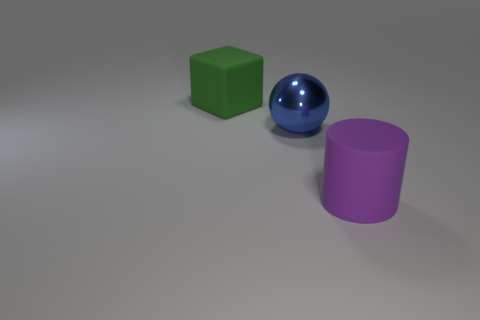How many big things are both to the right of the big green cube and on the left side of the purple object?
Give a very brief answer. 1. What material is the thing that is behind the blue ball?
Provide a succinct answer. Rubber. How many other objects have the same color as the big metallic thing?
Your answer should be compact. 0. There is a green cube that is made of the same material as the cylinder; what is its size?
Your answer should be compact. Large. How many things are either purple cylinders or red rubber cubes?
Your answer should be compact. 1. There is a rubber thing left of the large purple cylinder; what color is it?
Offer a very short reply. Green. What number of objects are large rubber objects left of the large purple matte cylinder or things on the right side of the green matte cube?
Keep it short and to the point. 3. There is a thing that is both to the right of the green object and behind the purple rubber thing; what is its size?
Offer a very short reply. Large. There is a big blue object; is its shape the same as the matte thing behind the purple matte cylinder?
Your response must be concise. No. What number of objects are big things that are in front of the blue sphere or balls?
Give a very brief answer. 2. 